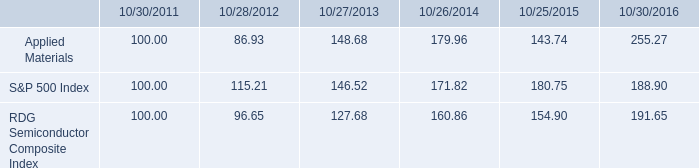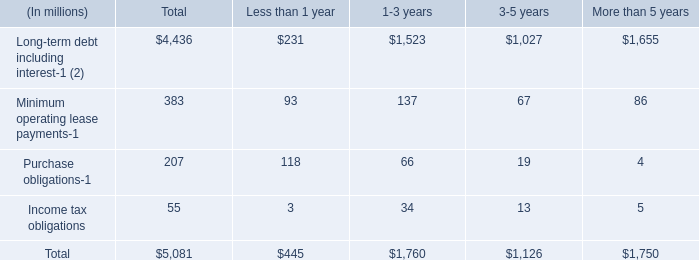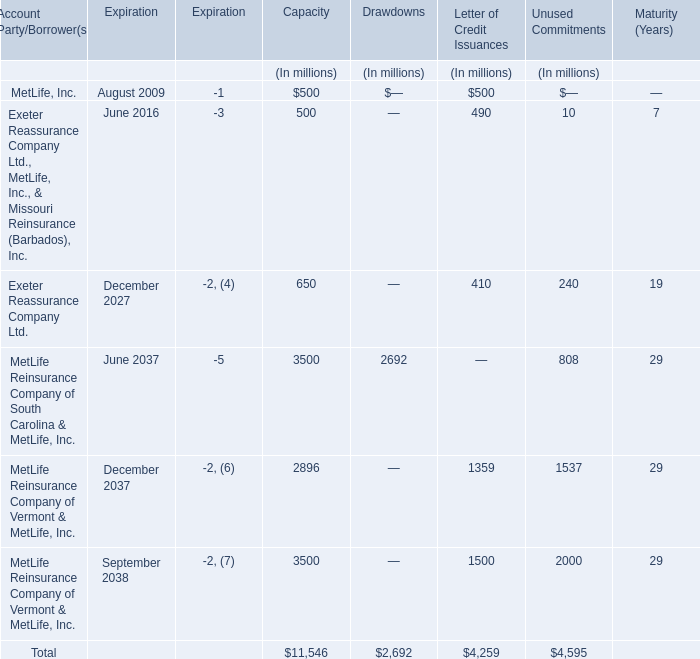What's the sum of all Letter of Credit Issuances that are greater than 1000 for Letter of Credit Issuances? (in million) 
Computations: (1359 + 1500)
Answer: 2859.0. 